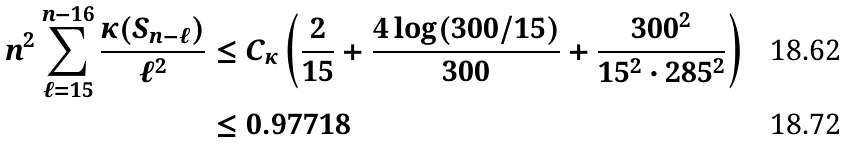<formula> <loc_0><loc_0><loc_500><loc_500>n ^ { 2 } \sum _ { \ell = 1 5 } ^ { n - 1 6 } \frac { \kappa ( S _ { n - \ell } ) } { \ell ^ { 2 } } & \leq C _ { \kappa } \left ( \frac { 2 } { 1 5 } + \frac { 4 \log ( 3 0 0 / 1 5 ) } { 3 0 0 } + \frac { 3 0 0 ^ { 2 } } { 1 5 ^ { 2 } \cdot 2 8 5 ^ { 2 } } \right ) \\ & \leq 0 . 9 7 7 1 8</formula> 